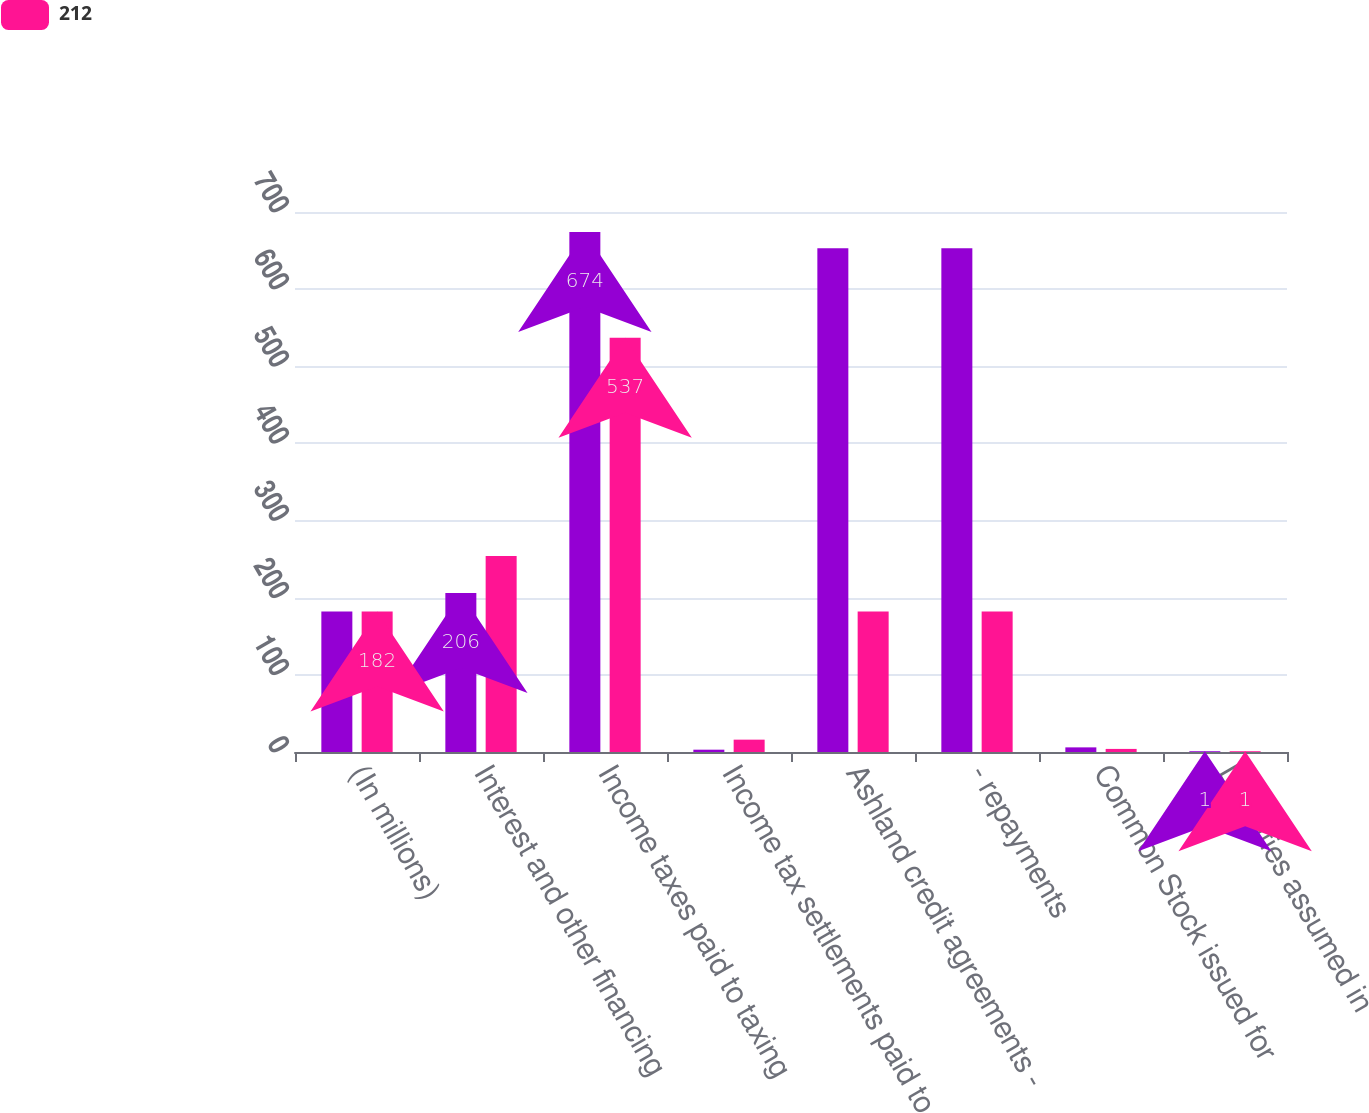Convert chart. <chart><loc_0><loc_0><loc_500><loc_500><stacked_bar_chart><ecel><fcel>(In millions)<fcel>Interest and other financing<fcel>Income taxes paid to taxing<fcel>Income tax settlements paid to<fcel>Ashland credit agreements -<fcel>- repayments<fcel>Common Stock issued for<fcel>Liabilities assumed in<nl><fcel>nan<fcel>182<fcel>206<fcel>674<fcel>3<fcel>653<fcel>653<fcel>6<fcel>1<nl><fcel>212<fcel>182<fcel>254<fcel>537<fcel>16<fcel>182<fcel>182<fcel>4<fcel>1<nl></chart> 